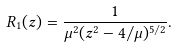<formula> <loc_0><loc_0><loc_500><loc_500>R _ { 1 } ( z ) = \frac { 1 } { \mu ^ { 2 } ( z ^ { 2 } - 4 / \mu ) ^ { 5 / 2 } } .</formula> 